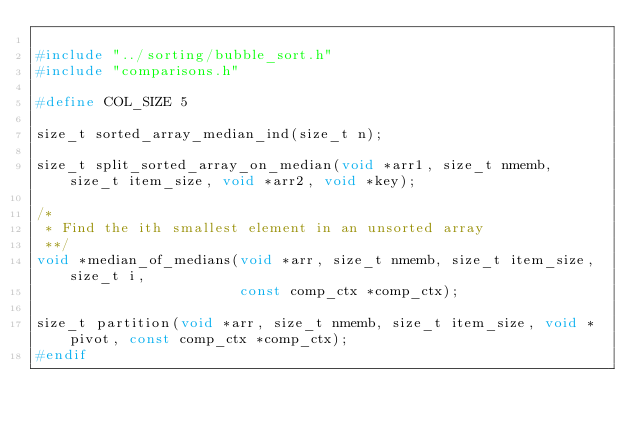<code> <loc_0><loc_0><loc_500><loc_500><_C_>
#include "../sorting/bubble_sort.h"
#include "comparisons.h"

#define COL_SIZE 5

size_t sorted_array_median_ind(size_t n);

size_t split_sorted_array_on_median(void *arr1, size_t nmemb, size_t item_size, void *arr2, void *key);

/*
 * Find the ith smallest element in an unsorted array
 **/
void *median_of_medians(void *arr, size_t nmemb, size_t item_size, size_t i,
                        const comp_ctx *comp_ctx);

size_t partition(void *arr, size_t nmemb, size_t item_size, void *pivot, const comp_ctx *comp_ctx);
#endif
</code> 